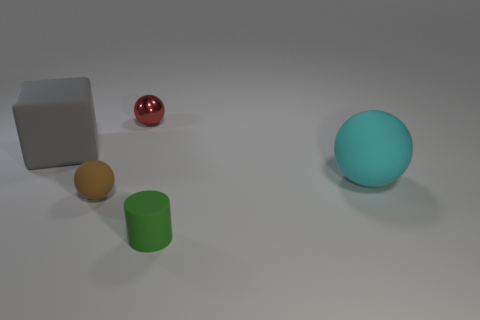What material is the sphere behind the matte object behind the large matte ball?
Your answer should be very brief. Metal. There is another matte thing that is the same shape as the brown thing; what size is it?
Your answer should be compact. Large. Is the color of the tiny sphere that is behind the tiny brown rubber ball the same as the matte cylinder?
Offer a terse response. No. Is the number of yellow cubes less than the number of small green cylinders?
Keep it short and to the point. Yes. Are the thing in front of the tiny brown matte thing and the brown sphere made of the same material?
Offer a terse response. Yes. What is the brown sphere that is behind the matte cylinder made of?
Make the answer very short. Rubber. There is a matte thing that is in front of the tiny ball in front of the cyan rubber sphere; what size is it?
Your answer should be very brief. Small. Is there a big red cylinder made of the same material as the cyan sphere?
Your answer should be very brief. No. What is the shape of the thing that is behind the large object to the left of the ball that is behind the large gray block?
Ensure brevity in your answer.  Sphere. Are there any other things that are the same size as the metal object?
Keep it short and to the point. Yes. 